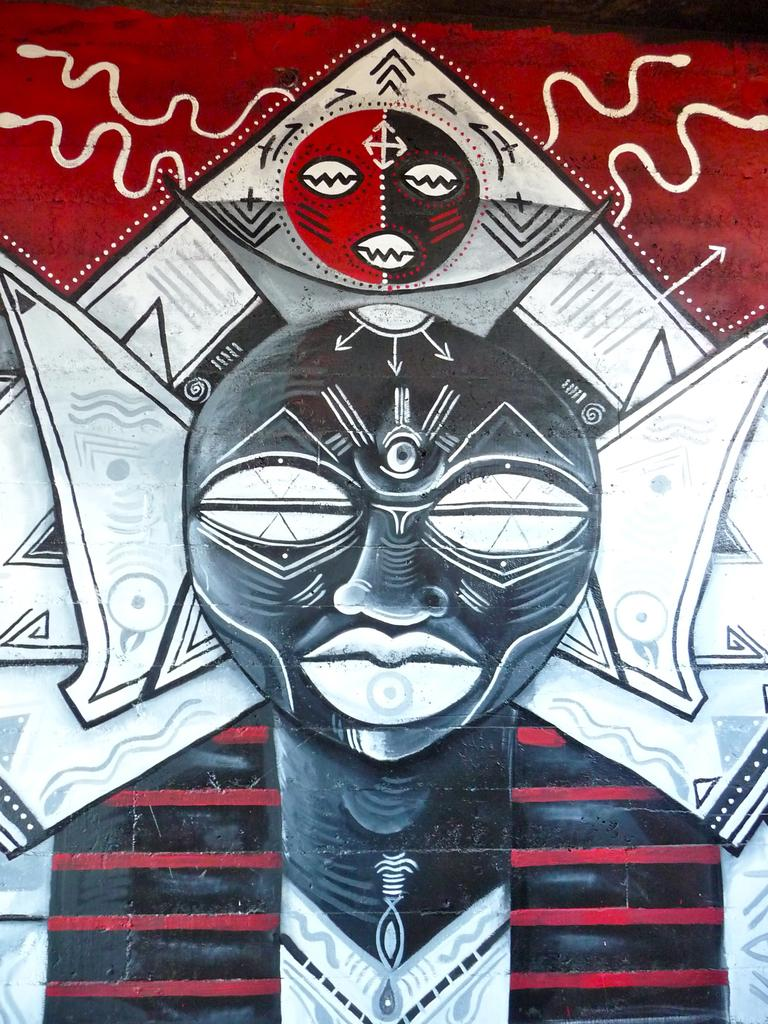What type of image is this? The image appears to be animated. Who or what is the main subject in the image? There is a person depicted in the center of the image. Are there any other objects or characters in the image? Yes, there are other objects present in the image. What type of thread is being used by the person in the image? There is no thread present in the image, as it is an animated scene and not a sewing project. 